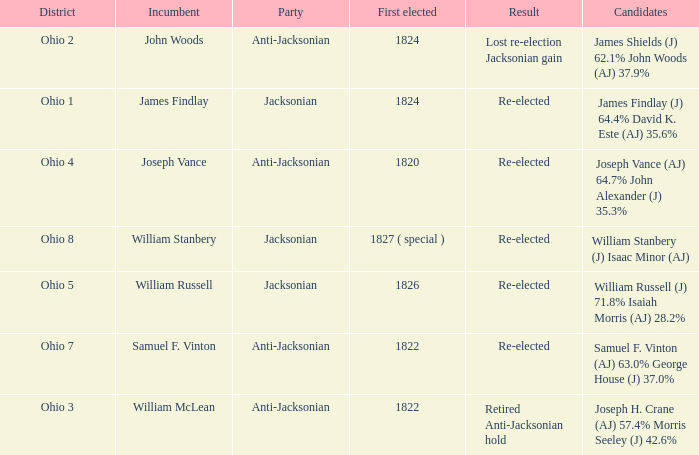What was the result for the candidate first elected in 1820? Re-elected. 